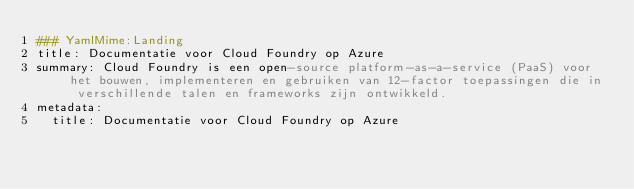Convert code to text. <code><loc_0><loc_0><loc_500><loc_500><_YAML_>### YamlMime:Landing
title: Documentatie voor Cloud Foundry op Azure
summary: Cloud Foundry is een open-source platform-as-a-service (PaaS) voor het bouwen, implementeren en gebruiken van 12-factor toepassingen die in verschillende talen en frameworks zijn ontwikkeld.
metadata:
  title: Documentatie voor Cloud Foundry op Azure</code> 